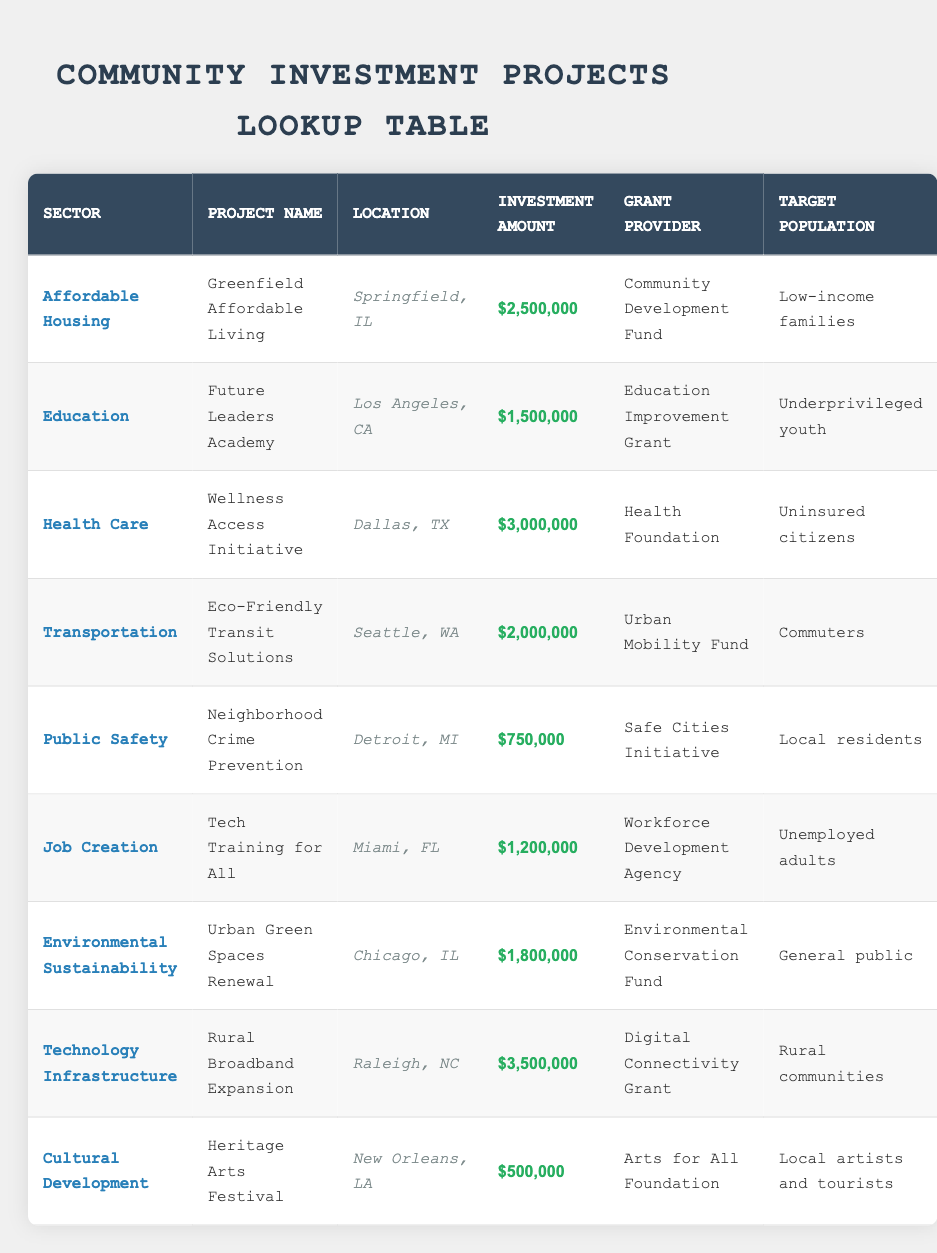What is the total investment amount for all community projects listed? To find the total investment amount, we sum up the investment amounts of all projects: 2500000 + 1500000 + 3000000 + 2000000 + 750000 + 1200000 + 1800000 + 3500000 + 500000 = 14150000.
Answer: 14150000 Which sector received the highest investment, and how much was it? Reviewing the table, the sector with the highest investment is Technology Infrastructure with an investment amount of 3500000.
Answer: Technology Infrastructure, 3500000 Is there any project targeting uninsured citizens? Yes, checking the "Target Population" column reveals that the "Wellness Access Initiative" project targets uninsured citizens.
Answer: Yes What is the average investment amount across these projects? To find the average, we first sum the investments (as calculated previously: 14150000), then divide by the number of projects (9), which equals 14150000 / 9 = 1572222.22. Rounding it gives approximately 1572222.
Answer: Approximately 1572222 How many projects are located in Illinois? Looking for the "Location" column, there are two projects located in Illinois: "Greenfield Affordable Living" in Springfield and "Urban Green Spaces Renewal" in Chicago.
Answer: 2 Did any project in 2022 have an investment amount less than 1 million dollars? No, all investment amounts listed in the table are greater than or equal to 500000, which is the lowest investment for the "Heritage Arts Festival."
Answer: No What are the target populations for projects in the Education sector? The only project in the Education sector is the "Future Leaders Academy," which targets underprivileged youth according to the "Target Population" column.
Answer: Underprivileged youth What is the difference in investment amount between the highest and lowest funded projects? The highest investment is 3500000 for "Rural Broadband Expansion," and the lowest is 500000 for "Heritage Arts Festival." The difference is 3500000 - 500000 = 3000000.
Answer: 3000000 Which grant provider funded the project intended for low-income families? The project aimed at low-income families is "Greenfield Affordable Living," funded by the "Community Development Fund."
Answer: Community Development Fund 